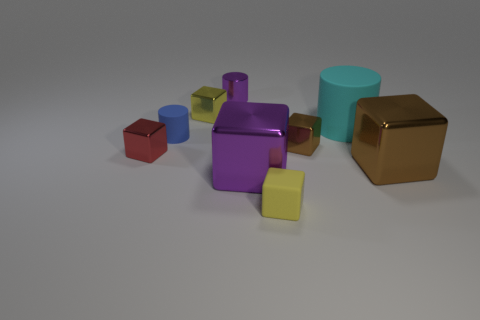Subtract all rubber cylinders. How many cylinders are left? 1 Subtract all green balls. How many brown cubes are left? 2 Subtract all cyan cylinders. How many cylinders are left? 2 Subtract all cylinders. How many objects are left? 6 Subtract all red blocks. Subtract all blue cylinders. How many blocks are left? 5 Subtract all small gray shiny spheres. Subtract all tiny brown objects. How many objects are left? 8 Add 9 purple shiny cylinders. How many purple shiny cylinders are left? 10 Add 8 green spheres. How many green spheres exist? 8 Subtract 0 gray cylinders. How many objects are left? 9 